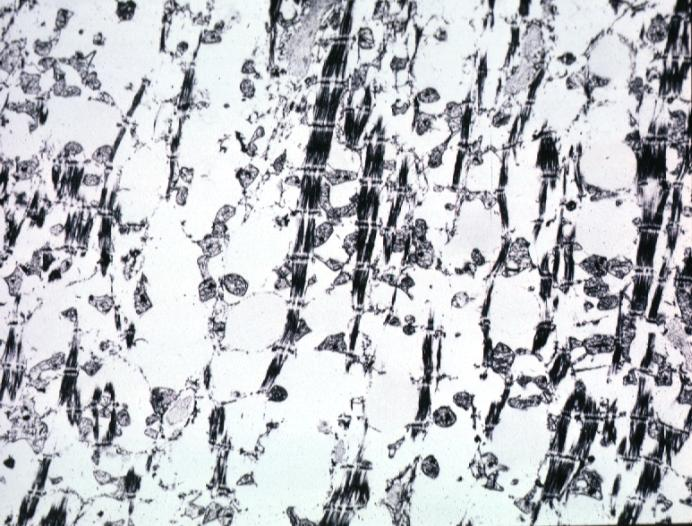what does formalin fixed and not too good but does show lesion of myocytolysis contain?
Answer the question using a single word or phrase. Not lipid 